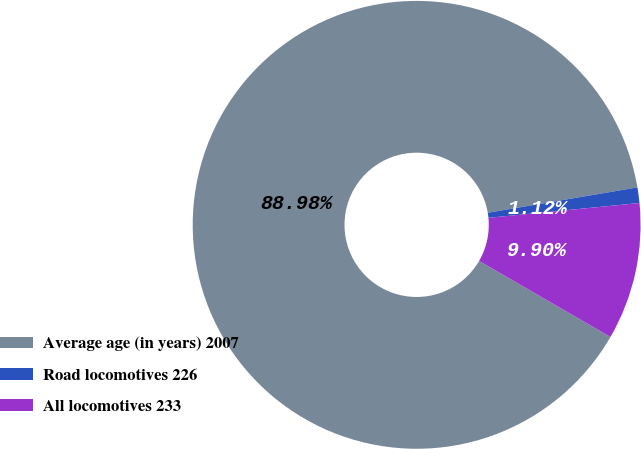Convert chart to OTSL. <chart><loc_0><loc_0><loc_500><loc_500><pie_chart><fcel>Average age (in years) 2007<fcel>Road locomotives 226<fcel>All locomotives 233<nl><fcel>88.98%<fcel>1.12%<fcel>9.9%<nl></chart> 